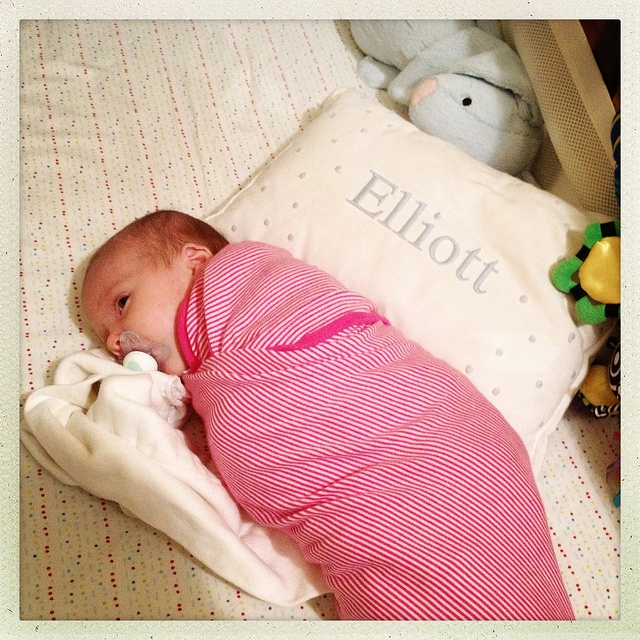Describe the objects in this image and their specific colors. I can see bed in lightgray, beige, lightpink, and tan tones, people in beige, lightpink, pink, brown, and salmon tones, teddy bear in beige, darkgray, gray, and lightgray tones, and teddy bear in beige, lightgray, darkgray, and gray tones in this image. 